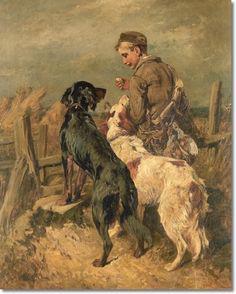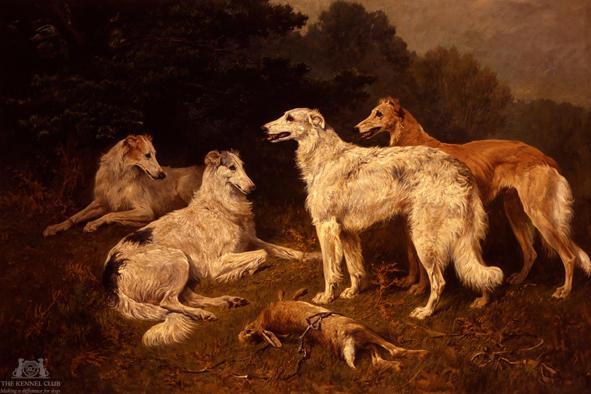The first image is the image on the left, the second image is the image on the right. Analyze the images presented: Is the assertion "Both images in the pair are paintings of dogs and not real dogs." valid? Answer yes or no. Yes. 